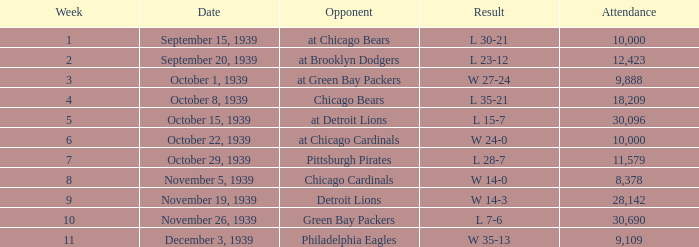Which attendance includes an opponent of green bay packers, and a week greater than 10? None. 